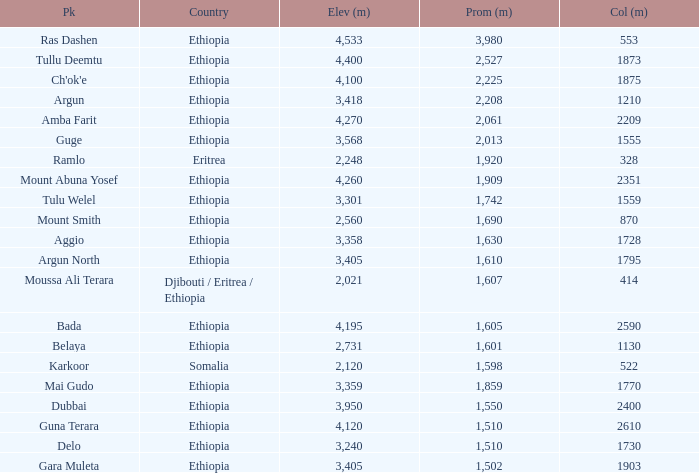What is the sum of the prominence in m of moussa ali terara peak? 1607.0. 